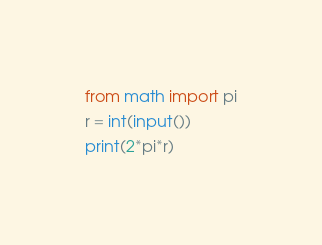<code> <loc_0><loc_0><loc_500><loc_500><_Python_>from math import pi
r = int(input())
print(2*pi*r)</code> 